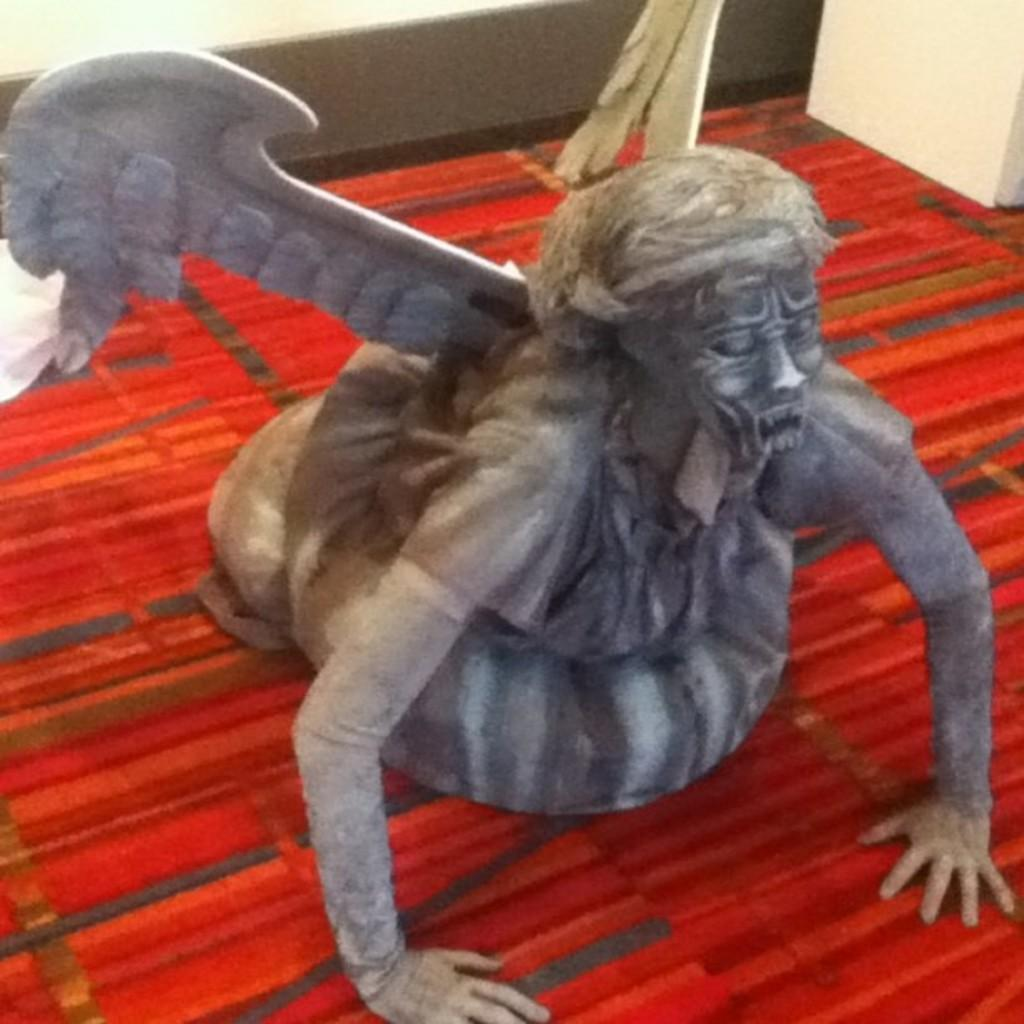What is the main subject of the picture? The main subject of the picture is a sculpture. What is located at the bottom of the sculpture? There is a mat at the bottom of the sculpture. What can be seen behind the sculpture? There is a wall visible at the back of the sculpture. How many servants are attending to the sculpture in the image? There are no servants present in the image; it only features a sculpture, a mat, and a wall. What invention is being demonstrated by the sculpture in the image? The sculpture in the image is not demonstrating any invention; it is a standalone piece of art. 